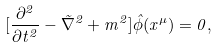Convert formula to latex. <formula><loc_0><loc_0><loc_500><loc_500>[ \frac { \partial ^ { 2 } } { \partial t ^ { 2 } } - \vec { \nabla } ^ { 2 } + m ^ { 2 } ] \hat { \phi } ( x ^ { \mu } ) = 0 ,</formula> 